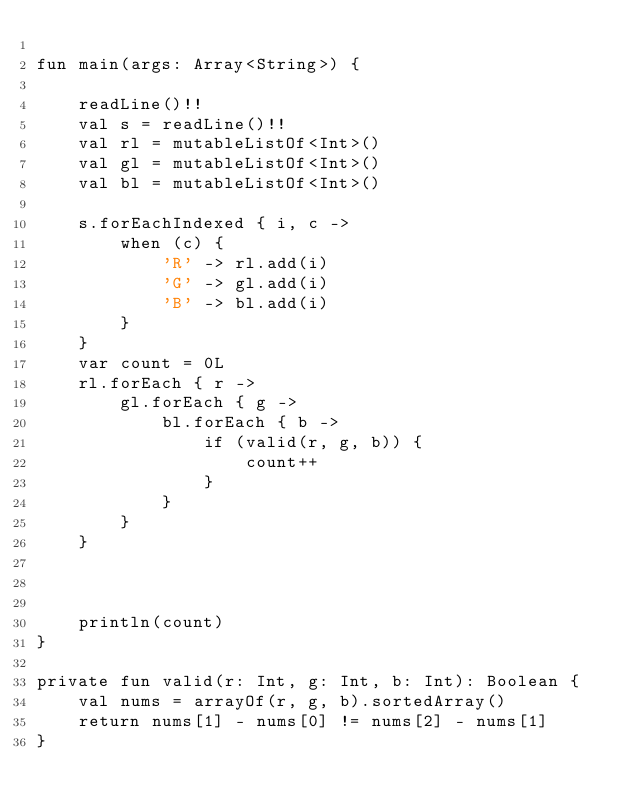Convert code to text. <code><loc_0><loc_0><loc_500><loc_500><_Kotlin_>
fun main(args: Array<String>) {

    readLine()!!
    val s = readLine()!!
    val rl = mutableListOf<Int>()
    val gl = mutableListOf<Int>()
    val bl = mutableListOf<Int>()

    s.forEachIndexed { i, c ->
        when (c) {
            'R' -> rl.add(i)
            'G' -> gl.add(i)
            'B' -> bl.add(i)
        }
    }
    var count = 0L
    rl.forEach { r ->
        gl.forEach { g ->
            bl.forEach { b ->
                if (valid(r, g, b)) {
                    count++
                }
            }
        }
    }



    println(count)
}

private fun valid(r: Int, g: Int, b: Int): Boolean {
    val nums = arrayOf(r, g, b).sortedArray()
    return nums[1] - nums[0] != nums[2] - nums[1]
}
</code> 